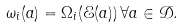Convert formula to latex. <formula><loc_0><loc_0><loc_500><loc_500>\omega _ { i } ( a ) = \Omega _ { i } ( \mathcal { E } ( a ) ) \, \forall a \in \mathcal { D } .</formula> 